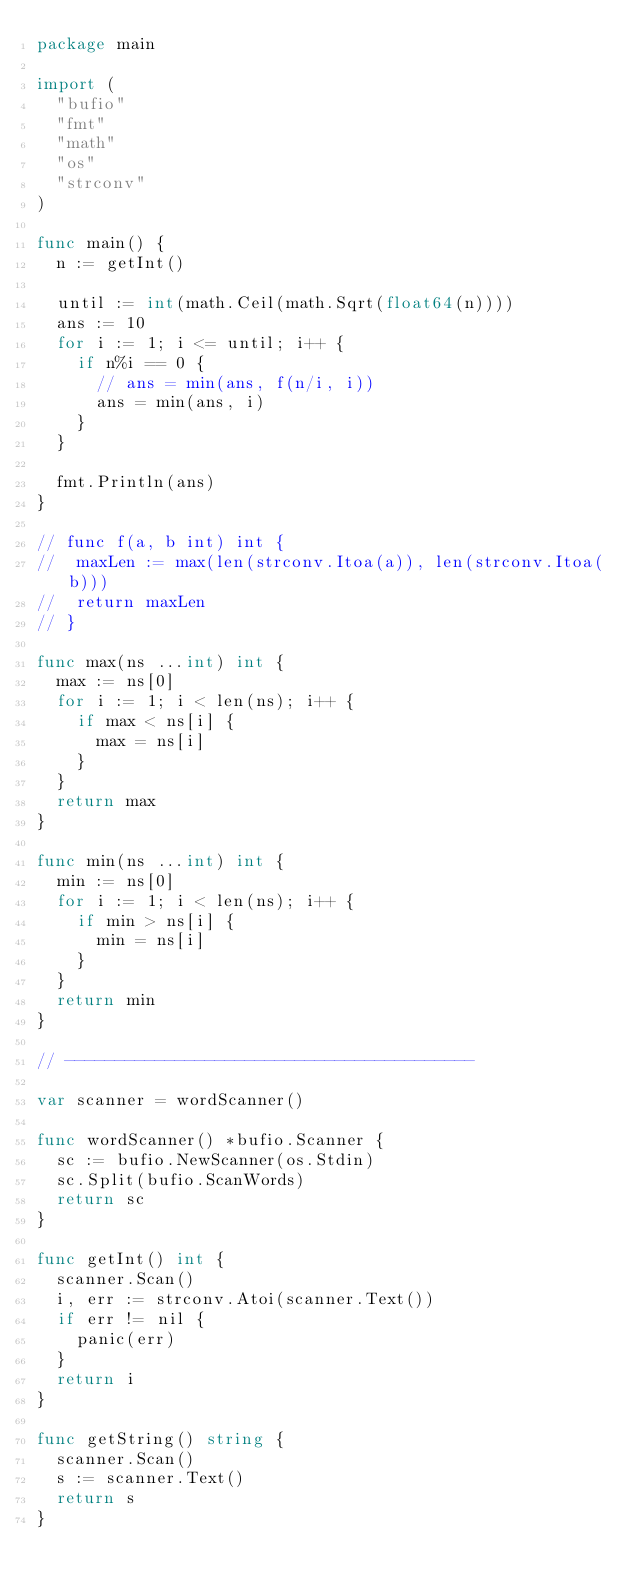<code> <loc_0><loc_0><loc_500><loc_500><_Go_>package main

import (
	"bufio"
	"fmt"
	"math"
	"os"
	"strconv"
)

func main() {
	n := getInt()

	until := int(math.Ceil(math.Sqrt(float64(n))))
	ans := 10
	for i := 1; i <= until; i++ {
		if n%i == 0 {
			// ans = min(ans, f(n/i, i))
			ans = min(ans, i)
		}
	}

	fmt.Println(ans)
}

// func f(a, b int) int {
// 	maxLen := max(len(strconv.Itoa(a)), len(strconv.Itoa(b)))
// 	return maxLen
// }

func max(ns ...int) int {
	max := ns[0]
	for i := 1; i < len(ns); i++ {
		if max < ns[i] {
			max = ns[i]
		}
	}
	return max
}

func min(ns ...int) int {
	min := ns[0]
	for i := 1; i < len(ns); i++ {
		if min > ns[i] {
			min = ns[i]
		}
	}
	return min
}

// -----------------------------------------

var scanner = wordScanner()

func wordScanner() *bufio.Scanner {
	sc := bufio.NewScanner(os.Stdin)
	sc.Split(bufio.ScanWords)
	return sc
}

func getInt() int {
	scanner.Scan()
	i, err := strconv.Atoi(scanner.Text())
	if err != nil {
		panic(err)
	}
	return i
}

func getString() string {
	scanner.Scan()
	s := scanner.Text()
	return s
}
</code> 